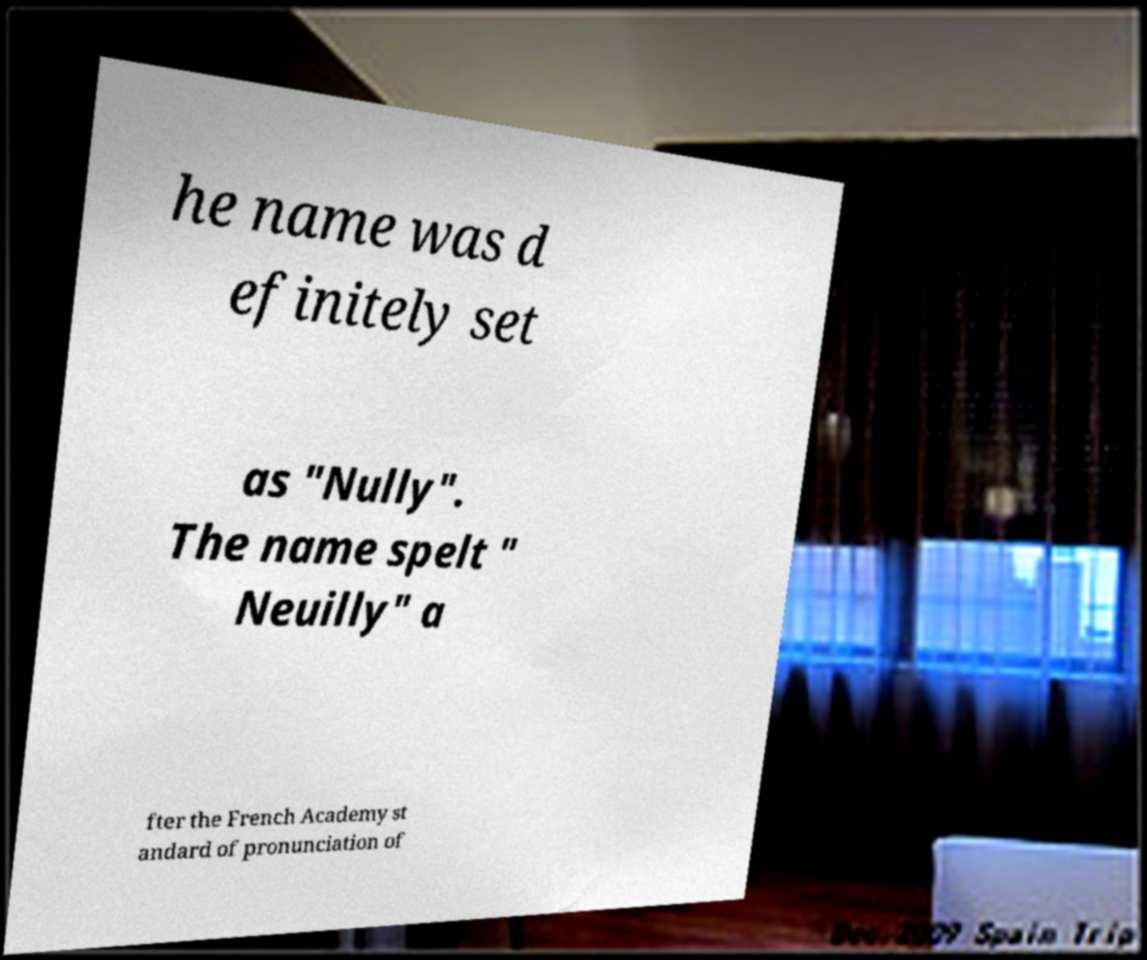For documentation purposes, I need the text within this image transcribed. Could you provide that? he name was d efinitely set as "Nully". The name spelt " Neuilly" a fter the French Academy st andard of pronunciation of 